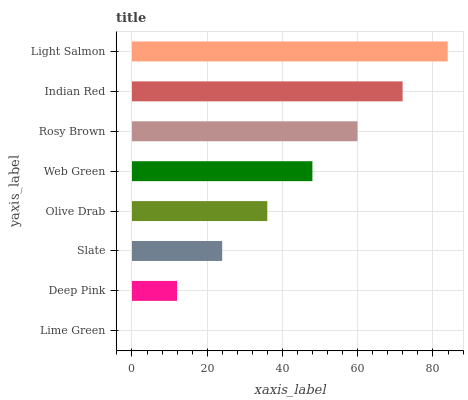Is Lime Green the minimum?
Answer yes or no. Yes. Is Light Salmon the maximum?
Answer yes or no. Yes. Is Deep Pink the minimum?
Answer yes or no. No. Is Deep Pink the maximum?
Answer yes or no. No. Is Deep Pink greater than Lime Green?
Answer yes or no. Yes. Is Lime Green less than Deep Pink?
Answer yes or no. Yes. Is Lime Green greater than Deep Pink?
Answer yes or no. No. Is Deep Pink less than Lime Green?
Answer yes or no. No. Is Web Green the high median?
Answer yes or no. Yes. Is Olive Drab the low median?
Answer yes or no. Yes. Is Light Salmon the high median?
Answer yes or no. No. Is Deep Pink the low median?
Answer yes or no. No. 